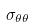<formula> <loc_0><loc_0><loc_500><loc_500>\sigma _ { \theta \theta }</formula> 